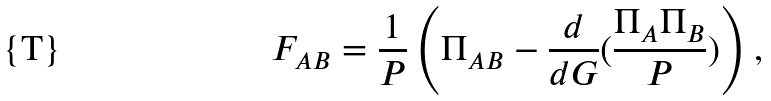Convert formula to latex. <formula><loc_0><loc_0><loc_500><loc_500>F _ { A B } = \frac { 1 } { P } \left ( \Pi _ { A B } - \frac { d } { d G } ( \frac { \Pi _ { A } \Pi _ { B } } { P } ) \right ) ,</formula> 